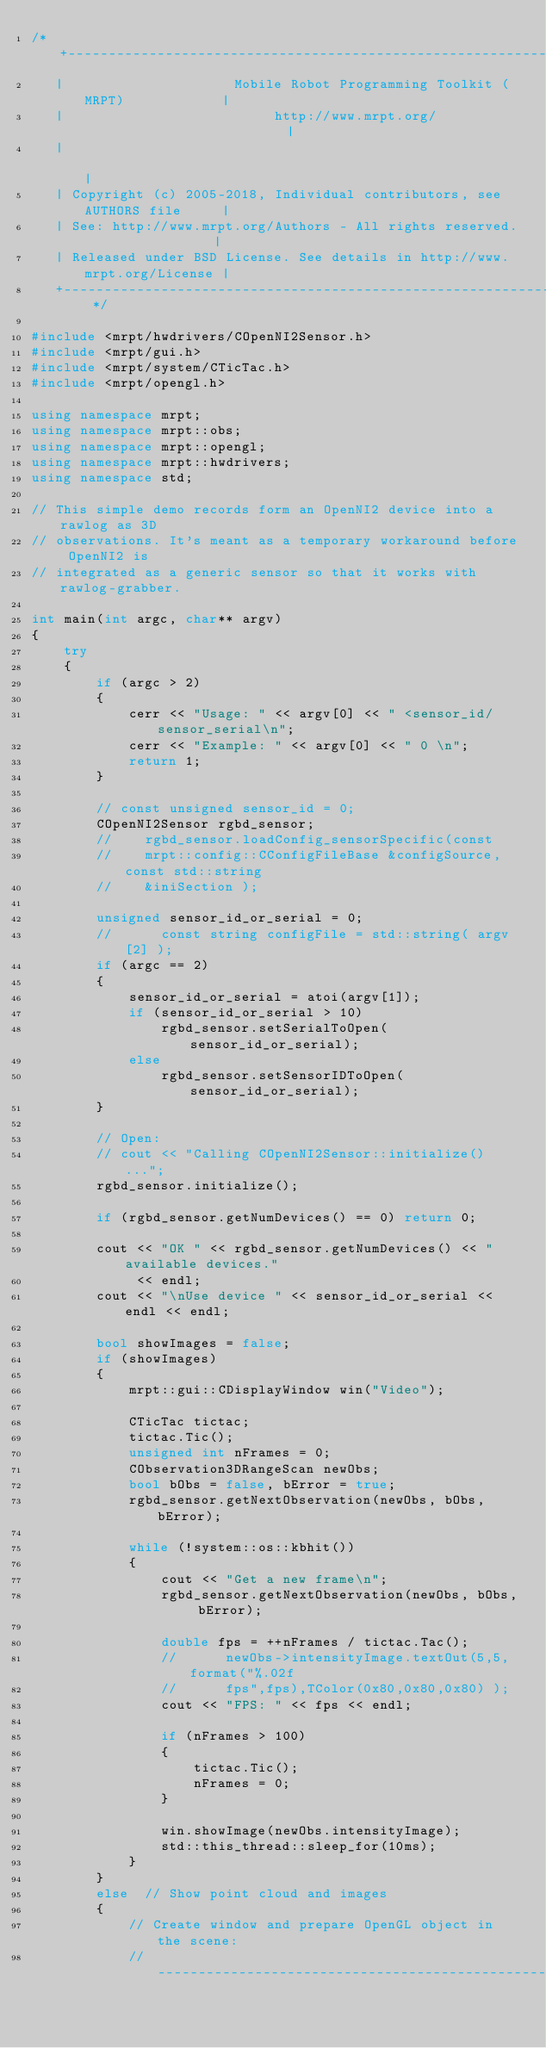<code> <loc_0><loc_0><loc_500><loc_500><_C++_>/* +------------------------------------------------------------------------+
   |                     Mobile Robot Programming Toolkit (MRPT)            |
   |                          http://www.mrpt.org/                          |
   |                                                                        |
   | Copyright (c) 2005-2018, Individual contributors, see AUTHORS file     |
   | See: http://www.mrpt.org/Authors - All rights reserved.                |
   | Released under BSD License. See details in http://www.mrpt.org/License |
   +------------------------------------------------------------------------+ */

#include <mrpt/hwdrivers/COpenNI2Sensor.h>
#include <mrpt/gui.h>
#include <mrpt/system/CTicTac.h>
#include <mrpt/opengl.h>

using namespace mrpt;
using namespace mrpt::obs;
using namespace mrpt::opengl;
using namespace mrpt::hwdrivers;
using namespace std;

// This simple demo records form an OpenNI2 device into a rawlog as 3D
// observations. It's meant as a temporary workaround before OpenNI2 is
// integrated as a generic sensor so that it works with rawlog-grabber.

int main(int argc, char** argv)
{
	try
	{
		if (argc > 2)
		{
			cerr << "Usage: " << argv[0] << " <sensor_id/sensor_serial\n";
			cerr << "Example: " << argv[0] << " 0 \n";
			return 1;
		}

		// const unsigned sensor_id = 0;
		COpenNI2Sensor rgbd_sensor;
		//    rgbd_sensor.loadConfig_sensorSpecific(const
		//    mrpt::config::CConfigFileBase &configSource,	const std::string
		//    &iniSection );

		unsigned sensor_id_or_serial = 0;
		//		const string configFile = std::string( argv[2] );
		if (argc == 2)
		{
			sensor_id_or_serial = atoi(argv[1]);
			if (sensor_id_or_serial > 10)
				rgbd_sensor.setSerialToOpen(sensor_id_or_serial);
			else
				rgbd_sensor.setSensorIDToOpen(sensor_id_or_serial);
		}

		// Open:
		// cout << "Calling COpenNI2Sensor::initialize()...";
		rgbd_sensor.initialize();

		if (rgbd_sensor.getNumDevices() == 0) return 0;

		cout << "OK " << rgbd_sensor.getNumDevices() << " available devices."
			 << endl;
		cout << "\nUse device " << sensor_id_or_serial << endl << endl;

		bool showImages = false;
		if (showImages)
		{
			mrpt::gui::CDisplayWindow win("Video");

			CTicTac tictac;
			tictac.Tic();
			unsigned int nFrames = 0;
			CObservation3DRangeScan newObs;
			bool bObs = false, bError = true;
			rgbd_sensor.getNextObservation(newObs, bObs, bError);

			while (!system::os::kbhit())
			{
				cout << "Get a new frame\n";
				rgbd_sensor.getNextObservation(newObs, bObs, bError);

				double fps = ++nFrames / tictac.Tac();
				//      newObs->intensityImage.textOut(5,5,format("%.02f
				//      fps",fps),TColor(0x80,0x80,0x80) );
				cout << "FPS: " << fps << endl;

				if (nFrames > 100)
				{
					tictac.Tic();
					nFrames = 0;
				}

				win.showImage(newObs.intensityImage);
				std::this_thread::sleep_for(10ms);
			}
		}
		else  // Show point cloud and images
		{
			// Create window and prepare OpenGL object in the scene:
			// --------------------------------------------------------</code> 